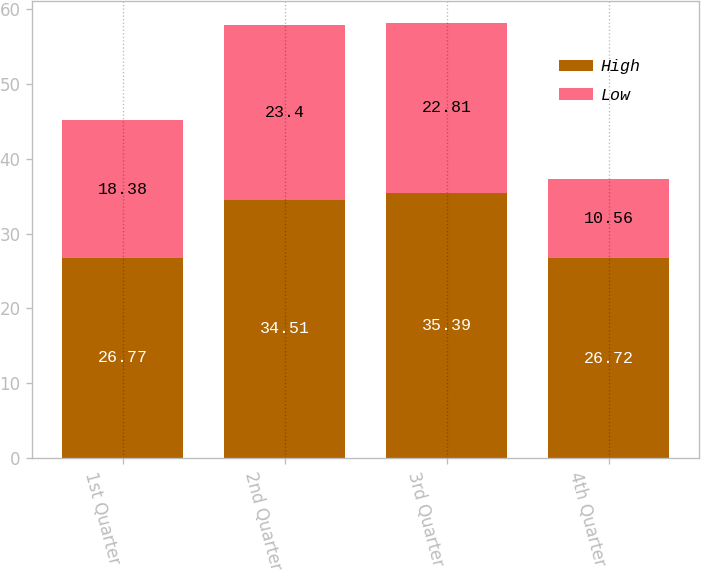Convert chart to OTSL. <chart><loc_0><loc_0><loc_500><loc_500><stacked_bar_chart><ecel><fcel>1st Quarter<fcel>2nd Quarter<fcel>3rd Quarter<fcel>4th Quarter<nl><fcel>High<fcel>26.77<fcel>34.51<fcel>35.39<fcel>26.72<nl><fcel>Low<fcel>18.38<fcel>23.4<fcel>22.81<fcel>10.56<nl></chart> 